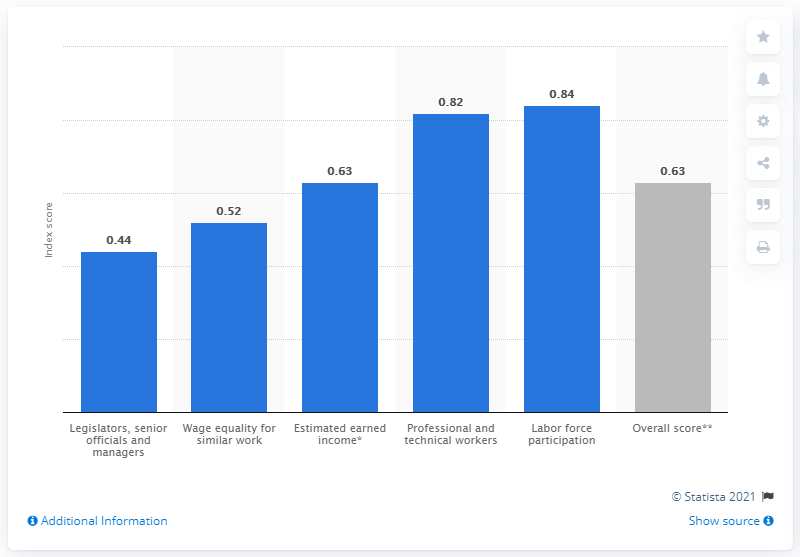Draw attention to some important aspects in this diagram. Peru's gender gap index score in 2021 was 0.63. This indicates that in 2021, Peru had a small gender gap, with women and men having a similar level of access to opportunities and resources. However, it is important to note that the gender gap is not fully closed, and further efforts are needed to achieve gender equality. According to estimates, Peru's earned income in 2021 was 0.63. 